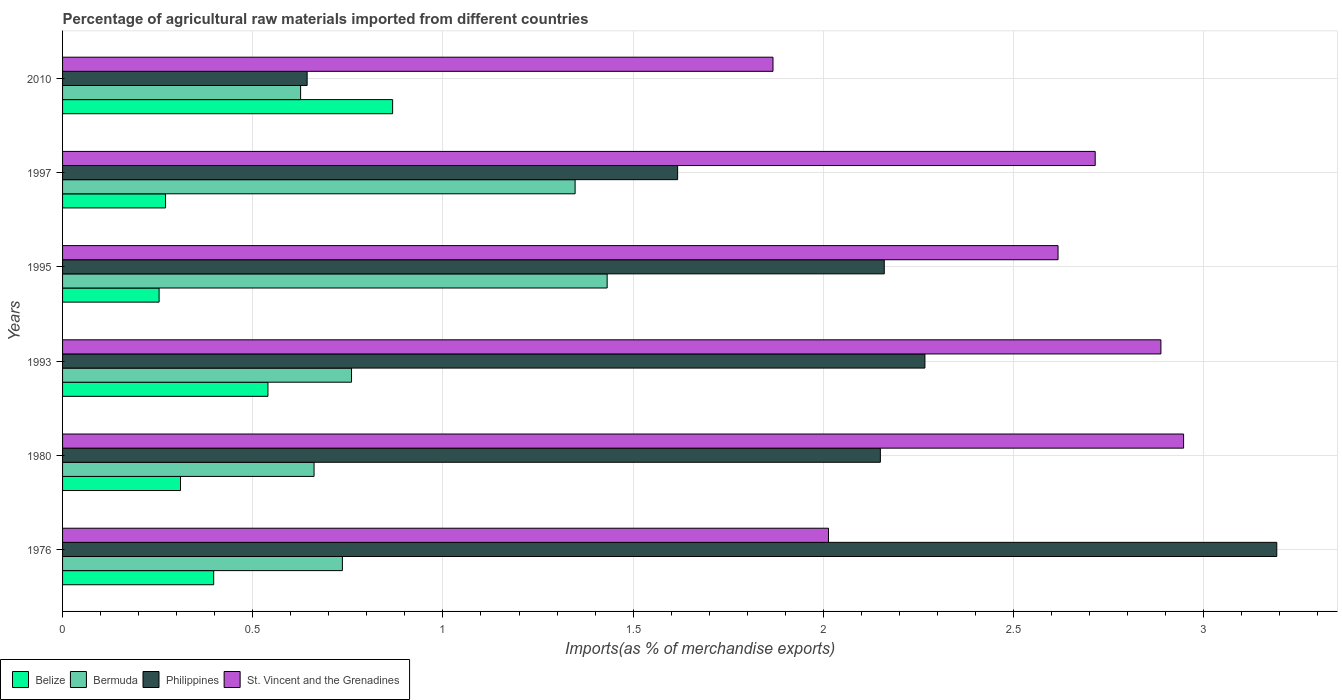How many different coloured bars are there?
Provide a succinct answer. 4. How many bars are there on the 6th tick from the top?
Provide a short and direct response. 4. What is the label of the 4th group of bars from the top?
Offer a very short reply. 1993. What is the percentage of imports to different countries in Belize in 1993?
Ensure brevity in your answer.  0.54. Across all years, what is the maximum percentage of imports to different countries in Philippines?
Provide a short and direct response. 3.19. Across all years, what is the minimum percentage of imports to different countries in Philippines?
Make the answer very short. 0.64. In which year was the percentage of imports to different countries in Philippines maximum?
Give a very brief answer. 1976. In which year was the percentage of imports to different countries in Bermuda minimum?
Make the answer very short. 2010. What is the total percentage of imports to different countries in Bermuda in the graph?
Offer a very short reply. 5.56. What is the difference between the percentage of imports to different countries in Philippines in 1995 and that in 2010?
Your answer should be very brief. 1.52. What is the difference between the percentage of imports to different countries in St. Vincent and the Grenadines in 1993 and the percentage of imports to different countries in Philippines in 1980?
Offer a very short reply. 0.74. What is the average percentage of imports to different countries in Philippines per year?
Your response must be concise. 2. In the year 1997, what is the difference between the percentage of imports to different countries in Belize and percentage of imports to different countries in St. Vincent and the Grenadines?
Your answer should be very brief. -2.44. What is the ratio of the percentage of imports to different countries in Belize in 1976 to that in 1997?
Provide a succinct answer. 1.47. Is the percentage of imports to different countries in Bermuda in 1993 less than that in 1997?
Your answer should be compact. Yes. What is the difference between the highest and the second highest percentage of imports to different countries in St. Vincent and the Grenadines?
Ensure brevity in your answer.  0.06. What is the difference between the highest and the lowest percentage of imports to different countries in Philippines?
Give a very brief answer. 2.55. What does the 1st bar from the top in 1997 represents?
Keep it short and to the point. St. Vincent and the Grenadines. What does the 4th bar from the bottom in 2010 represents?
Offer a terse response. St. Vincent and the Grenadines. How many bars are there?
Your answer should be very brief. 24. Are all the bars in the graph horizontal?
Ensure brevity in your answer.  Yes. What is the difference between two consecutive major ticks on the X-axis?
Your answer should be very brief. 0.5. Does the graph contain any zero values?
Provide a short and direct response. No. Where does the legend appear in the graph?
Offer a very short reply. Bottom left. How many legend labels are there?
Your answer should be very brief. 4. What is the title of the graph?
Offer a very short reply. Percentage of agricultural raw materials imported from different countries. Does "Least developed countries" appear as one of the legend labels in the graph?
Make the answer very short. No. What is the label or title of the X-axis?
Keep it short and to the point. Imports(as % of merchandise exports). What is the label or title of the Y-axis?
Provide a succinct answer. Years. What is the Imports(as % of merchandise exports) in Belize in 1976?
Make the answer very short. 0.4. What is the Imports(as % of merchandise exports) of Bermuda in 1976?
Provide a succinct answer. 0.74. What is the Imports(as % of merchandise exports) of Philippines in 1976?
Keep it short and to the point. 3.19. What is the Imports(as % of merchandise exports) of St. Vincent and the Grenadines in 1976?
Your answer should be very brief. 2.01. What is the Imports(as % of merchandise exports) of Belize in 1980?
Your answer should be very brief. 0.31. What is the Imports(as % of merchandise exports) of Bermuda in 1980?
Make the answer very short. 0.66. What is the Imports(as % of merchandise exports) in Philippines in 1980?
Provide a short and direct response. 2.15. What is the Imports(as % of merchandise exports) of St. Vincent and the Grenadines in 1980?
Your answer should be compact. 2.95. What is the Imports(as % of merchandise exports) in Belize in 1993?
Ensure brevity in your answer.  0.54. What is the Imports(as % of merchandise exports) in Bermuda in 1993?
Offer a very short reply. 0.76. What is the Imports(as % of merchandise exports) of Philippines in 1993?
Ensure brevity in your answer.  2.27. What is the Imports(as % of merchandise exports) in St. Vincent and the Grenadines in 1993?
Keep it short and to the point. 2.89. What is the Imports(as % of merchandise exports) in Belize in 1995?
Your response must be concise. 0.25. What is the Imports(as % of merchandise exports) in Bermuda in 1995?
Provide a short and direct response. 1.43. What is the Imports(as % of merchandise exports) of Philippines in 1995?
Provide a short and direct response. 2.16. What is the Imports(as % of merchandise exports) of St. Vincent and the Grenadines in 1995?
Your answer should be compact. 2.62. What is the Imports(as % of merchandise exports) of Belize in 1997?
Your response must be concise. 0.27. What is the Imports(as % of merchandise exports) in Bermuda in 1997?
Give a very brief answer. 1.35. What is the Imports(as % of merchandise exports) of Philippines in 1997?
Your answer should be very brief. 1.62. What is the Imports(as % of merchandise exports) in St. Vincent and the Grenadines in 1997?
Offer a very short reply. 2.71. What is the Imports(as % of merchandise exports) in Belize in 2010?
Keep it short and to the point. 0.87. What is the Imports(as % of merchandise exports) of Bermuda in 2010?
Offer a very short reply. 0.63. What is the Imports(as % of merchandise exports) in Philippines in 2010?
Your answer should be compact. 0.64. What is the Imports(as % of merchandise exports) of St. Vincent and the Grenadines in 2010?
Your response must be concise. 1.87. Across all years, what is the maximum Imports(as % of merchandise exports) of Belize?
Provide a succinct answer. 0.87. Across all years, what is the maximum Imports(as % of merchandise exports) of Bermuda?
Offer a terse response. 1.43. Across all years, what is the maximum Imports(as % of merchandise exports) in Philippines?
Ensure brevity in your answer.  3.19. Across all years, what is the maximum Imports(as % of merchandise exports) in St. Vincent and the Grenadines?
Your answer should be compact. 2.95. Across all years, what is the minimum Imports(as % of merchandise exports) in Belize?
Your response must be concise. 0.25. Across all years, what is the minimum Imports(as % of merchandise exports) in Bermuda?
Offer a very short reply. 0.63. Across all years, what is the minimum Imports(as % of merchandise exports) in Philippines?
Offer a very short reply. 0.64. Across all years, what is the minimum Imports(as % of merchandise exports) in St. Vincent and the Grenadines?
Offer a terse response. 1.87. What is the total Imports(as % of merchandise exports) in Belize in the graph?
Your answer should be compact. 2.64. What is the total Imports(as % of merchandise exports) in Bermuda in the graph?
Your answer should be compact. 5.56. What is the total Imports(as % of merchandise exports) of Philippines in the graph?
Your answer should be compact. 12.03. What is the total Imports(as % of merchandise exports) of St. Vincent and the Grenadines in the graph?
Offer a terse response. 15.05. What is the difference between the Imports(as % of merchandise exports) of Belize in 1976 and that in 1980?
Your answer should be compact. 0.09. What is the difference between the Imports(as % of merchandise exports) of Bermuda in 1976 and that in 1980?
Your response must be concise. 0.07. What is the difference between the Imports(as % of merchandise exports) of Philippines in 1976 and that in 1980?
Make the answer very short. 1.04. What is the difference between the Imports(as % of merchandise exports) in St. Vincent and the Grenadines in 1976 and that in 1980?
Offer a very short reply. -0.93. What is the difference between the Imports(as % of merchandise exports) in Belize in 1976 and that in 1993?
Ensure brevity in your answer.  -0.14. What is the difference between the Imports(as % of merchandise exports) of Bermuda in 1976 and that in 1993?
Your response must be concise. -0.02. What is the difference between the Imports(as % of merchandise exports) in Philippines in 1976 and that in 1993?
Keep it short and to the point. 0.93. What is the difference between the Imports(as % of merchandise exports) of St. Vincent and the Grenadines in 1976 and that in 1993?
Keep it short and to the point. -0.87. What is the difference between the Imports(as % of merchandise exports) in Belize in 1976 and that in 1995?
Keep it short and to the point. 0.14. What is the difference between the Imports(as % of merchandise exports) of Bermuda in 1976 and that in 1995?
Ensure brevity in your answer.  -0.7. What is the difference between the Imports(as % of merchandise exports) of Philippines in 1976 and that in 1995?
Provide a short and direct response. 1.03. What is the difference between the Imports(as % of merchandise exports) in St. Vincent and the Grenadines in 1976 and that in 1995?
Offer a very short reply. -0.6. What is the difference between the Imports(as % of merchandise exports) in Belize in 1976 and that in 1997?
Offer a very short reply. 0.13. What is the difference between the Imports(as % of merchandise exports) in Bermuda in 1976 and that in 1997?
Provide a short and direct response. -0.61. What is the difference between the Imports(as % of merchandise exports) in Philippines in 1976 and that in 1997?
Ensure brevity in your answer.  1.58. What is the difference between the Imports(as % of merchandise exports) of St. Vincent and the Grenadines in 1976 and that in 1997?
Ensure brevity in your answer.  -0.7. What is the difference between the Imports(as % of merchandise exports) of Belize in 1976 and that in 2010?
Your response must be concise. -0.47. What is the difference between the Imports(as % of merchandise exports) of Bermuda in 1976 and that in 2010?
Your response must be concise. 0.11. What is the difference between the Imports(as % of merchandise exports) in Philippines in 1976 and that in 2010?
Offer a very short reply. 2.55. What is the difference between the Imports(as % of merchandise exports) of St. Vincent and the Grenadines in 1976 and that in 2010?
Keep it short and to the point. 0.15. What is the difference between the Imports(as % of merchandise exports) in Belize in 1980 and that in 1993?
Keep it short and to the point. -0.23. What is the difference between the Imports(as % of merchandise exports) of Bermuda in 1980 and that in 1993?
Make the answer very short. -0.1. What is the difference between the Imports(as % of merchandise exports) in Philippines in 1980 and that in 1993?
Offer a very short reply. -0.12. What is the difference between the Imports(as % of merchandise exports) of St. Vincent and the Grenadines in 1980 and that in 1993?
Your answer should be compact. 0.06. What is the difference between the Imports(as % of merchandise exports) in Belize in 1980 and that in 1995?
Your answer should be very brief. 0.06. What is the difference between the Imports(as % of merchandise exports) of Bermuda in 1980 and that in 1995?
Keep it short and to the point. -0.77. What is the difference between the Imports(as % of merchandise exports) of Philippines in 1980 and that in 1995?
Offer a terse response. -0.01. What is the difference between the Imports(as % of merchandise exports) in St. Vincent and the Grenadines in 1980 and that in 1995?
Offer a terse response. 0.33. What is the difference between the Imports(as % of merchandise exports) in Belize in 1980 and that in 1997?
Make the answer very short. 0.04. What is the difference between the Imports(as % of merchandise exports) of Bermuda in 1980 and that in 1997?
Your answer should be compact. -0.69. What is the difference between the Imports(as % of merchandise exports) in Philippines in 1980 and that in 1997?
Your response must be concise. 0.53. What is the difference between the Imports(as % of merchandise exports) in St. Vincent and the Grenadines in 1980 and that in 1997?
Give a very brief answer. 0.23. What is the difference between the Imports(as % of merchandise exports) of Belize in 1980 and that in 2010?
Offer a terse response. -0.56. What is the difference between the Imports(as % of merchandise exports) of Bermuda in 1980 and that in 2010?
Ensure brevity in your answer.  0.04. What is the difference between the Imports(as % of merchandise exports) of Philippines in 1980 and that in 2010?
Offer a very short reply. 1.51. What is the difference between the Imports(as % of merchandise exports) in St. Vincent and the Grenadines in 1980 and that in 2010?
Provide a short and direct response. 1.08. What is the difference between the Imports(as % of merchandise exports) of Belize in 1993 and that in 1995?
Make the answer very short. 0.29. What is the difference between the Imports(as % of merchandise exports) in Bermuda in 1993 and that in 1995?
Give a very brief answer. -0.67. What is the difference between the Imports(as % of merchandise exports) in Philippines in 1993 and that in 1995?
Offer a very short reply. 0.11. What is the difference between the Imports(as % of merchandise exports) of St. Vincent and the Grenadines in 1993 and that in 1995?
Provide a succinct answer. 0.27. What is the difference between the Imports(as % of merchandise exports) of Belize in 1993 and that in 1997?
Your answer should be compact. 0.27. What is the difference between the Imports(as % of merchandise exports) of Bermuda in 1993 and that in 1997?
Ensure brevity in your answer.  -0.59. What is the difference between the Imports(as % of merchandise exports) in Philippines in 1993 and that in 1997?
Provide a succinct answer. 0.65. What is the difference between the Imports(as % of merchandise exports) of St. Vincent and the Grenadines in 1993 and that in 1997?
Offer a terse response. 0.17. What is the difference between the Imports(as % of merchandise exports) in Belize in 1993 and that in 2010?
Give a very brief answer. -0.33. What is the difference between the Imports(as % of merchandise exports) in Bermuda in 1993 and that in 2010?
Ensure brevity in your answer.  0.13. What is the difference between the Imports(as % of merchandise exports) in Philippines in 1993 and that in 2010?
Make the answer very short. 1.62. What is the difference between the Imports(as % of merchandise exports) of St. Vincent and the Grenadines in 1993 and that in 2010?
Keep it short and to the point. 1.02. What is the difference between the Imports(as % of merchandise exports) in Belize in 1995 and that in 1997?
Make the answer very short. -0.02. What is the difference between the Imports(as % of merchandise exports) of Bermuda in 1995 and that in 1997?
Your response must be concise. 0.08. What is the difference between the Imports(as % of merchandise exports) in Philippines in 1995 and that in 1997?
Provide a short and direct response. 0.54. What is the difference between the Imports(as % of merchandise exports) of St. Vincent and the Grenadines in 1995 and that in 1997?
Provide a succinct answer. -0.1. What is the difference between the Imports(as % of merchandise exports) in Belize in 1995 and that in 2010?
Provide a succinct answer. -0.61. What is the difference between the Imports(as % of merchandise exports) of Bermuda in 1995 and that in 2010?
Provide a succinct answer. 0.81. What is the difference between the Imports(as % of merchandise exports) in Philippines in 1995 and that in 2010?
Your answer should be compact. 1.52. What is the difference between the Imports(as % of merchandise exports) in St. Vincent and the Grenadines in 1995 and that in 2010?
Offer a very short reply. 0.75. What is the difference between the Imports(as % of merchandise exports) of Belize in 1997 and that in 2010?
Give a very brief answer. -0.6. What is the difference between the Imports(as % of merchandise exports) of Bermuda in 1997 and that in 2010?
Offer a terse response. 0.72. What is the difference between the Imports(as % of merchandise exports) of Philippines in 1997 and that in 2010?
Offer a very short reply. 0.97. What is the difference between the Imports(as % of merchandise exports) in St. Vincent and the Grenadines in 1997 and that in 2010?
Provide a short and direct response. 0.85. What is the difference between the Imports(as % of merchandise exports) in Belize in 1976 and the Imports(as % of merchandise exports) in Bermuda in 1980?
Your response must be concise. -0.26. What is the difference between the Imports(as % of merchandise exports) in Belize in 1976 and the Imports(as % of merchandise exports) in Philippines in 1980?
Provide a succinct answer. -1.75. What is the difference between the Imports(as % of merchandise exports) in Belize in 1976 and the Imports(as % of merchandise exports) in St. Vincent and the Grenadines in 1980?
Ensure brevity in your answer.  -2.55. What is the difference between the Imports(as % of merchandise exports) in Bermuda in 1976 and the Imports(as % of merchandise exports) in Philippines in 1980?
Offer a terse response. -1.41. What is the difference between the Imports(as % of merchandise exports) in Bermuda in 1976 and the Imports(as % of merchandise exports) in St. Vincent and the Grenadines in 1980?
Make the answer very short. -2.21. What is the difference between the Imports(as % of merchandise exports) of Philippines in 1976 and the Imports(as % of merchandise exports) of St. Vincent and the Grenadines in 1980?
Ensure brevity in your answer.  0.24. What is the difference between the Imports(as % of merchandise exports) of Belize in 1976 and the Imports(as % of merchandise exports) of Bermuda in 1993?
Give a very brief answer. -0.36. What is the difference between the Imports(as % of merchandise exports) in Belize in 1976 and the Imports(as % of merchandise exports) in Philippines in 1993?
Provide a short and direct response. -1.87. What is the difference between the Imports(as % of merchandise exports) of Belize in 1976 and the Imports(as % of merchandise exports) of St. Vincent and the Grenadines in 1993?
Provide a succinct answer. -2.49. What is the difference between the Imports(as % of merchandise exports) of Bermuda in 1976 and the Imports(as % of merchandise exports) of Philippines in 1993?
Provide a short and direct response. -1.53. What is the difference between the Imports(as % of merchandise exports) of Bermuda in 1976 and the Imports(as % of merchandise exports) of St. Vincent and the Grenadines in 1993?
Offer a terse response. -2.15. What is the difference between the Imports(as % of merchandise exports) in Philippines in 1976 and the Imports(as % of merchandise exports) in St. Vincent and the Grenadines in 1993?
Provide a short and direct response. 0.3. What is the difference between the Imports(as % of merchandise exports) of Belize in 1976 and the Imports(as % of merchandise exports) of Bermuda in 1995?
Offer a very short reply. -1.03. What is the difference between the Imports(as % of merchandise exports) in Belize in 1976 and the Imports(as % of merchandise exports) in Philippines in 1995?
Make the answer very short. -1.76. What is the difference between the Imports(as % of merchandise exports) in Belize in 1976 and the Imports(as % of merchandise exports) in St. Vincent and the Grenadines in 1995?
Your answer should be compact. -2.22. What is the difference between the Imports(as % of merchandise exports) of Bermuda in 1976 and the Imports(as % of merchandise exports) of Philippines in 1995?
Your answer should be very brief. -1.42. What is the difference between the Imports(as % of merchandise exports) in Bermuda in 1976 and the Imports(as % of merchandise exports) in St. Vincent and the Grenadines in 1995?
Your answer should be compact. -1.88. What is the difference between the Imports(as % of merchandise exports) in Philippines in 1976 and the Imports(as % of merchandise exports) in St. Vincent and the Grenadines in 1995?
Your response must be concise. 0.57. What is the difference between the Imports(as % of merchandise exports) of Belize in 1976 and the Imports(as % of merchandise exports) of Bermuda in 1997?
Your response must be concise. -0.95. What is the difference between the Imports(as % of merchandise exports) in Belize in 1976 and the Imports(as % of merchandise exports) in Philippines in 1997?
Ensure brevity in your answer.  -1.22. What is the difference between the Imports(as % of merchandise exports) of Belize in 1976 and the Imports(as % of merchandise exports) of St. Vincent and the Grenadines in 1997?
Ensure brevity in your answer.  -2.32. What is the difference between the Imports(as % of merchandise exports) in Bermuda in 1976 and the Imports(as % of merchandise exports) in Philippines in 1997?
Ensure brevity in your answer.  -0.88. What is the difference between the Imports(as % of merchandise exports) in Bermuda in 1976 and the Imports(as % of merchandise exports) in St. Vincent and the Grenadines in 1997?
Keep it short and to the point. -1.98. What is the difference between the Imports(as % of merchandise exports) of Philippines in 1976 and the Imports(as % of merchandise exports) of St. Vincent and the Grenadines in 1997?
Ensure brevity in your answer.  0.48. What is the difference between the Imports(as % of merchandise exports) in Belize in 1976 and the Imports(as % of merchandise exports) in Bermuda in 2010?
Your answer should be very brief. -0.23. What is the difference between the Imports(as % of merchandise exports) in Belize in 1976 and the Imports(as % of merchandise exports) in Philippines in 2010?
Your answer should be compact. -0.25. What is the difference between the Imports(as % of merchandise exports) in Belize in 1976 and the Imports(as % of merchandise exports) in St. Vincent and the Grenadines in 2010?
Your answer should be very brief. -1.47. What is the difference between the Imports(as % of merchandise exports) in Bermuda in 1976 and the Imports(as % of merchandise exports) in Philippines in 2010?
Offer a terse response. 0.09. What is the difference between the Imports(as % of merchandise exports) in Bermuda in 1976 and the Imports(as % of merchandise exports) in St. Vincent and the Grenadines in 2010?
Provide a succinct answer. -1.13. What is the difference between the Imports(as % of merchandise exports) in Philippines in 1976 and the Imports(as % of merchandise exports) in St. Vincent and the Grenadines in 2010?
Your answer should be compact. 1.32. What is the difference between the Imports(as % of merchandise exports) of Belize in 1980 and the Imports(as % of merchandise exports) of Bermuda in 1993?
Give a very brief answer. -0.45. What is the difference between the Imports(as % of merchandise exports) in Belize in 1980 and the Imports(as % of merchandise exports) in Philippines in 1993?
Your answer should be compact. -1.96. What is the difference between the Imports(as % of merchandise exports) in Belize in 1980 and the Imports(as % of merchandise exports) in St. Vincent and the Grenadines in 1993?
Your answer should be compact. -2.58. What is the difference between the Imports(as % of merchandise exports) in Bermuda in 1980 and the Imports(as % of merchandise exports) in Philippines in 1993?
Give a very brief answer. -1.61. What is the difference between the Imports(as % of merchandise exports) of Bermuda in 1980 and the Imports(as % of merchandise exports) of St. Vincent and the Grenadines in 1993?
Offer a very short reply. -2.23. What is the difference between the Imports(as % of merchandise exports) in Philippines in 1980 and the Imports(as % of merchandise exports) in St. Vincent and the Grenadines in 1993?
Make the answer very short. -0.74. What is the difference between the Imports(as % of merchandise exports) of Belize in 1980 and the Imports(as % of merchandise exports) of Bermuda in 1995?
Your response must be concise. -1.12. What is the difference between the Imports(as % of merchandise exports) in Belize in 1980 and the Imports(as % of merchandise exports) in Philippines in 1995?
Make the answer very short. -1.85. What is the difference between the Imports(as % of merchandise exports) of Belize in 1980 and the Imports(as % of merchandise exports) of St. Vincent and the Grenadines in 1995?
Provide a succinct answer. -2.31. What is the difference between the Imports(as % of merchandise exports) in Bermuda in 1980 and the Imports(as % of merchandise exports) in Philippines in 1995?
Give a very brief answer. -1.5. What is the difference between the Imports(as % of merchandise exports) of Bermuda in 1980 and the Imports(as % of merchandise exports) of St. Vincent and the Grenadines in 1995?
Your response must be concise. -1.96. What is the difference between the Imports(as % of merchandise exports) of Philippines in 1980 and the Imports(as % of merchandise exports) of St. Vincent and the Grenadines in 1995?
Your answer should be compact. -0.47. What is the difference between the Imports(as % of merchandise exports) in Belize in 1980 and the Imports(as % of merchandise exports) in Bermuda in 1997?
Your response must be concise. -1.04. What is the difference between the Imports(as % of merchandise exports) of Belize in 1980 and the Imports(as % of merchandise exports) of Philippines in 1997?
Provide a succinct answer. -1.31. What is the difference between the Imports(as % of merchandise exports) in Belize in 1980 and the Imports(as % of merchandise exports) in St. Vincent and the Grenadines in 1997?
Keep it short and to the point. -2.4. What is the difference between the Imports(as % of merchandise exports) of Bermuda in 1980 and the Imports(as % of merchandise exports) of Philippines in 1997?
Offer a very short reply. -0.96. What is the difference between the Imports(as % of merchandise exports) of Bermuda in 1980 and the Imports(as % of merchandise exports) of St. Vincent and the Grenadines in 1997?
Your answer should be very brief. -2.05. What is the difference between the Imports(as % of merchandise exports) of Philippines in 1980 and the Imports(as % of merchandise exports) of St. Vincent and the Grenadines in 1997?
Your answer should be very brief. -0.56. What is the difference between the Imports(as % of merchandise exports) of Belize in 1980 and the Imports(as % of merchandise exports) of Bermuda in 2010?
Offer a terse response. -0.32. What is the difference between the Imports(as % of merchandise exports) in Belize in 1980 and the Imports(as % of merchandise exports) in Philippines in 2010?
Provide a short and direct response. -0.33. What is the difference between the Imports(as % of merchandise exports) in Belize in 1980 and the Imports(as % of merchandise exports) in St. Vincent and the Grenadines in 2010?
Keep it short and to the point. -1.56. What is the difference between the Imports(as % of merchandise exports) of Bermuda in 1980 and the Imports(as % of merchandise exports) of Philippines in 2010?
Make the answer very short. 0.02. What is the difference between the Imports(as % of merchandise exports) of Bermuda in 1980 and the Imports(as % of merchandise exports) of St. Vincent and the Grenadines in 2010?
Give a very brief answer. -1.21. What is the difference between the Imports(as % of merchandise exports) in Philippines in 1980 and the Imports(as % of merchandise exports) in St. Vincent and the Grenadines in 2010?
Provide a short and direct response. 0.28. What is the difference between the Imports(as % of merchandise exports) in Belize in 1993 and the Imports(as % of merchandise exports) in Bermuda in 1995?
Your answer should be very brief. -0.89. What is the difference between the Imports(as % of merchandise exports) of Belize in 1993 and the Imports(as % of merchandise exports) of Philippines in 1995?
Your answer should be compact. -1.62. What is the difference between the Imports(as % of merchandise exports) of Belize in 1993 and the Imports(as % of merchandise exports) of St. Vincent and the Grenadines in 1995?
Offer a terse response. -2.08. What is the difference between the Imports(as % of merchandise exports) of Bermuda in 1993 and the Imports(as % of merchandise exports) of Philippines in 1995?
Your response must be concise. -1.4. What is the difference between the Imports(as % of merchandise exports) in Bermuda in 1993 and the Imports(as % of merchandise exports) in St. Vincent and the Grenadines in 1995?
Your response must be concise. -1.86. What is the difference between the Imports(as % of merchandise exports) in Philippines in 1993 and the Imports(as % of merchandise exports) in St. Vincent and the Grenadines in 1995?
Provide a short and direct response. -0.35. What is the difference between the Imports(as % of merchandise exports) in Belize in 1993 and the Imports(as % of merchandise exports) in Bermuda in 1997?
Offer a terse response. -0.81. What is the difference between the Imports(as % of merchandise exports) of Belize in 1993 and the Imports(as % of merchandise exports) of Philippines in 1997?
Give a very brief answer. -1.08. What is the difference between the Imports(as % of merchandise exports) of Belize in 1993 and the Imports(as % of merchandise exports) of St. Vincent and the Grenadines in 1997?
Your response must be concise. -2.17. What is the difference between the Imports(as % of merchandise exports) of Bermuda in 1993 and the Imports(as % of merchandise exports) of Philippines in 1997?
Your response must be concise. -0.86. What is the difference between the Imports(as % of merchandise exports) of Bermuda in 1993 and the Imports(as % of merchandise exports) of St. Vincent and the Grenadines in 1997?
Ensure brevity in your answer.  -1.96. What is the difference between the Imports(as % of merchandise exports) in Philippines in 1993 and the Imports(as % of merchandise exports) in St. Vincent and the Grenadines in 1997?
Provide a succinct answer. -0.45. What is the difference between the Imports(as % of merchandise exports) in Belize in 1993 and the Imports(as % of merchandise exports) in Bermuda in 2010?
Offer a terse response. -0.09. What is the difference between the Imports(as % of merchandise exports) in Belize in 1993 and the Imports(as % of merchandise exports) in Philippines in 2010?
Provide a succinct answer. -0.1. What is the difference between the Imports(as % of merchandise exports) in Belize in 1993 and the Imports(as % of merchandise exports) in St. Vincent and the Grenadines in 2010?
Make the answer very short. -1.33. What is the difference between the Imports(as % of merchandise exports) in Bermuda in 1993 and the Imports(as % of merchandise exports) in Philippines in 2010?
Your answer should be compact. 0.12. What is the difference between the Imports(as % of merchandise exports) in Bermuda in 1993 and the Imports(as % of merchandise exports) in St. Vincent and the Grenadines in 2010?
Provide a short and direct response. -1.11. What is the difference between the Imports(as % of merchandise exports) of Philippines in 1993 and the Imports(as % of merchandise exports) of St. Vincent and the Grenadines in 2010?
Give a very brief answer. 0.4. What is the difference between the Imports(as % of merchandise exports) of Belize in 1995 and the Imports(as % of merchandise exports) of Bermuda in 1997?
Provide a succinct answer. -1.09. What is the difference between the Imports(as % of merchandise exports) in Belize in 1995 and the Imports(as % of merchandise exports) in Philippines in 1997?
Offer a very short reply. -1.36. What is the difference between the Imports(as % of merchandise exports) in Belize in 1995 and the Imports(as % of merchandise exports) in St. Vincent and the Grenadines in 1997?
Make the answer very short. -2.46. What is the difference between the Imports(as % of merchandise exports) of Bermuda in 1995 and the Imports(as % of merchandise exports) of Philippines in 1997?
Give a very brief answer. -0.19. What is the difference between the Imports(as % of merchandise exports) of Bermuda in 1995 and the Imports(as % of merchandise exports) of St. Vincent and the Grenadines in 1997?
Make the answer very short. -1.28. What is the difference between the Imports(as % of merchandise exports) in Philippines in 1995 and the Imports(as % of merchandise exports) in St. Vincent and the Grenadines in 1997?
Make the answer very short. -0.55. What is the difference between the Imports(as % of merchandise exports) of Belize in 1995 and the Imports(as % of merchandise exports) of Bermuda in 2010?
Your answer should be compact. -0.37. What is the difference between the Imports(as % of merchandise exports) in Belize in 1995 and the Imports(as % of merchandise exports) in Philippines in 2010?
Your answer should be very brief. -0.39. What is the difference between the Imports(as % of merchandise exports) of Belize in 1995 and the Imports(as % of merchandise exports) of St. Vincent and the Grenadines in 2010?
Your response must be concise. -1.61. What is the difference between the Imports(as % of merchandise exports) in Bermuda in 1995 and the Imports(as % of merchandise exports) in Philippines in 2010?
Provide a short and direct response. 0.79. What is the difference between the Imports(as % of merchandise exports) of Bermuda in 1995 and the Imports(as % of merchandise exports) of St. Vincent and the Grenadines in 2010?
Provide a short and direct response. -0.44. What is the difference between the Imports(as % of merchandise exports) of Philippines in 1995 and the Imports(as % of merchandise exports) of St. Vincent and the Grenadines in 2010?
Your response must be concise. 0.29. What is the difference between the Imports(as % of merchandise exports) in Belize in 1997 and the Imports(as % of merchandise exports) in Bermuda in 2010?
Ensure brevity in your answer.  -0.35. What is the difference between the Imports(as % of merchandise exports) of Belize in 1997 and the Imports(as % of merchandise exports) of Philippines in 2010?
Keep it short and to the point. -0.37. What is the difference between the Imports(as % of merchandise exports) of Belize in 1997 and the Imports(as % of merchandise exports) of St. Vincent and the Grenadines in 2010?
Ensure brevity in your answer.  -1.6. What is the difference between the Imports(as % of merchandise exports) of Bermuda in 1997 and the Imports(as % of merchandise exports) of Philippines in 2010?
Your response must be concise. 0.7. What is the difference between the Imports(as % of merchandise exports) of Bermuda in 1997 and the Imports(as % of merchandise exports) of St. Vincent and the Grenadines in 2010?
Make the answer very short. -0.52. What is the difference between the Imports(as % of merchandise exports) of Philippines in 1997 and the Imports(as % of merchandise exports) of St. Vincent and the Grenadines in 2010?
Offer a very short reply. -0.25. What is the average Imports(as % of merchandise exports) in Belize per year?
Offer a very short reply. 0.44. What is the average Imports(as % of merchandise exports) of Bermuda per year?
Keep it short and to the point. 0.93. What is the average Imports(as % of merchandise exports) in Philippines per year?
Give a very brief answer. 2. What is the average Imports(as % of merchandise exports) of St. Vincent and the Grenadines per year?
Provide a short and direct response. 2.51. In the year 1976, what is the difference between the Imports(as % of merchandise exports) in Belize and Imports(as % of merchandise exports) in Bermuda?
Ensure brevity in your answer.  -0.34. In the year 1976, what is the difference between the Imports(as % of merchandise exports) of Belize and Imports(as % of merchandise exports) of Philippines?
Provide a short and direct response. -2.79. In the year 1976, what is the difference between the Imports(as % of merchandise exports) in Belize and Imports(as % of merchandise exports) in St. Vincent and the Grenadines?
Ensure brevity in your answer.  -1.62. In the year 1976, what is the difference between the Imports(as % of merchandise exports) in Bermuda and Imports(as % of merchandise exports) in Philippines?
Provide a succinct answer. -2.46. In the year 1976, what is the difference between the Imports(as % of merchandise exports) of Bermuda and Imports(as % of merchandise exports) of St. Vincent and the Grenadines?
Offer a very short reply. -1.28. In the year 1976, what is the difference between the Imports(as % of merchandise exports) of Philippines and Imports(as % of merchandise exports) of St. Vincent and the Grenadines?
Your response must be concise. 1.18. In the year 1980, what is the difference between the Imports(as % of merchandise exports) in Belize and Imports(as % of merchandise exports) in Bermuda?
Offer a very short reply. -0.35. In the year 1980, what is the difference between the Imports(as % of merchandise exports) in Belize and Imports(as % of merchandise exports) in Philippines?
Make the answer very short. -1.84. In the year 1980, what is the difference between the Imports(as % of merchandise exports) of Belize and Imports(as % of merchandise exports) of St. Vincent and the Grenadines?
Give a very brief answer. -2.64. In the year 1980, what is the difference between the Imports(as % of merchandise exports) of Bermuda and Imports(as % of merchandise exports) of Philippines?
Make the answer very short. -1.49. In the year 1980, what is the difference between the Imports(as % of merchandise exports) of Bermuda and Imports(as % of merchandise exports) of St. Vincent and the Grenadines?
Offer a very short reply. -2.29. In the year 1980, what is the difference between the Imports(as % of merchandise exports) in Philippines and Imports(as % of merchandise exports) in St. Vincent and the Grenadines?
Your response must be concise. -0.8. In the year 1993, what is the difference between the Imports(as % of merchandise exports) of Belize and Imports(as % of merchandise exports) of Bermuda?
Your response must be concise. -0.22. In the year 1993, what is the difference between the Imports(as % of merchandise exports) of Belize and Imports(as % of merchandise exports) of Philippines?
Ensure brevity in your answer.  -1.73. In the year 1993, what is the difference between the Imports(as % of merchandise exports) of Belize and Imports(as % of merchandise exports) of St. Vincent and the Grenadines?
Give a very brief answer. -2.35. In the year 1993, what is the difference between the Imports(as % of merchandise exports) of Bermuda and Imports(as % of merchandise exports) of Philippines?
Keep it short and to the point. -1.51. In the year 1993, what is the difference between the Imports(as % of merchandise exports) in Bermuda and Imports(as % of merchandise exports) in St. Vincent and the Grenadines?
Offer a very short reply. -2.13. In the year 1993, what is the difference between the Imports(as % of merchandise exports) of Philippines and Imports(as % of merchandise exports) of St. Vincent and the Grenadines?
Keep it short and to the point. -0.62. In the year 1995, what is the difference between the Imports(as % of merchandise exports) in Belize and Imports(as % of merchandise exports) in Bermuda?
Your response must be concise. -1.18. In the year 1995, what is the difference between the Imports(as % of merchandise exports) of Belize and Imports(as % of merchandise exports) of Philippines?
Your answer should be very brief. -1.91. In the year 1995, what is the difference between the Imports(as % of merchandise exports) in Belize and Imports(as % of merchandise exports) in St. Vincent and the Grenadines?
Your response must be concise. -2.36. In the year 1995, what is the difference between the Imports(as % of merchandise exports) of Bermuda and Imports(as % of merchandise exports) of Philippines?
Your response must be concise. -0.73. In the year 1995, what is the difference between the Imports(as % of merchandise exports) of Bermuda and Imports(as % of merchandise exports) of St. Vincent and the Grenadines?
Your response must be concise. -1.19. In the year 1995, what is the difference between the Imports(as % of merchandise exports) of Philippines and Imports(as % of merchandise exports) of St. Vincent and the Grenadines?
Your answer should be very brief. -0.46. In the year 1997, what is the difference between the Imports(as % of merchandise exports) in Belize and Imports(as % of merchandise exports) in Bermuda?
Give a very brief answer. -1.08. In the year 1997, what is the difference between the Imports(as % of merchandise exports) of Belize and Imports(as % of merchandise exports) of Philippines?
Offer a terse response. -1.35. In the year 1997, what is the difference between the Imports(as % of merchandise exports) in Belize and Imports(as % of merchandise exports) in St. Vincent and the Grenadines?
Offer a terse response. -2.44. In the year 1997, what is the difference between the Imports(as % of merchandise exports) of Bermuda and Imports(as % of merchandise exports) of Philippines?
Your answer should be very brief. -0.27. In the year 1997, what is the difference between the Imports(as % of merchandise exports) of Bermuda and Imports(as % of merchandise exports) of St. Vincent and the Grenadines?
Provide a succinct answer. -1.37. In the year 1997, what is the difference between the Imports(as % of merchandise exports) of Philippines and Imports(as % of merchandise exports) of St. Vincent and the Grenadines?
Your answer should be very brief. -1.1. In the year 2010, what is the difference between the Imports(as % of merchandise exports) in Belize and Imports(as % of merchandise exports) in Bermuda?
Your response must be concise. 0.24. In the year 2010, what is the difference between the Imports(as % of merchandise exports) in Belize and Imports(as % of merchandise exports) in Philippines?
Offer a very short reply. 0.22. In the year 2010, what is the difference between the Imports(as % of merchandise exports) of Bermuda and Imports(as % of merchandise exports) of Philippines?
Offer a very short reply. -0.02. In the year 2010, what is the difference between the Imports(as % of merchandise exports) of Bermuda and Imports(as % of merchandise exports) of St. Vincent and the Grenadines?
Your answer should be very brief. -1.24. In the year 2010, what is the difference between the Imports(as % of merchandise exports) of Philippines and Imports(as % of merchandise exports) of St. Vincent and the Grenadines?
Offer a terse response. -1.22. What is the ratio of the Imports(as % of merchandise exports) in Belize in 1976 to that in 1980?
Your answer should be compact. 1.28. What is the ratio of the Imports(as % of merchandise exports) in Bermuda in 1976 to that in 1980?
Give a very brief answer. 1.11. What is the ratio of the Imports(as % of merchandise exports) of Philippines in 1976 to that in 1980?
Your answer should be very brief. 1.48. What is the ratio of the Imports(as % of merchandise exports) in St. Vincent and the Grenadines in 1976 to that in 1980?
Provide a succinct answer. 0.68. What is the ratio of the Imports(as % of merchandise exports) in Belize in 1976 to that in 1993?
Give a very brief answer. 0.74. What is the ratio of the Imports(as % of merchandise exports) in Bermuda in 1976 to that in 1993?
Offer a terse response. 0.97. What is the ratio of the Imports(as % of merchandise exports) in Philippines in 1976 to that in 1993?
Give a very brief answer. 1.41. What is the ratio of the Imports(as % of merchandise exports) in St. Vincent and the Grenadines in 1976 to that in 1993?
Make the answer very short. 0.7. What is the ratio of the Imports(as % of merchandise exports) in Belize in 1976 to that in 1995?
Provide a short and direct response. 1.57. What is the ratio of the Imports(as % of merchandise exports) in Bermuda in 1976 to that in 1995?
Your response must be concise. 0.51. What is the ratio of the Imports(as % of merchandise exports) in Philippines in 1976 to that in 1995?
Your answer should be very brief. 1.48. What is the ratio of the Imports(as % of merchandise exports) of St. Vincent and the Grenadines in 1976 to that in 1995?
Ensure brevity in your answer.  0.77. What is the ratio of the Imports(as % of merchandise exports) in Belize in 1976 to that in 1997?
Make the answer very short. 1.47. What is the ratio of the Imports(as % of merchandise exports) in Bermuda in 1976 to that in 1997?
Make the answer very short. 0.55. What is the ratio of the Imports(as % of merchandise exports) of Philippines in 1976 to that in 1997?
Your response must be concise. 1.97. What is the ratio of the Imports(as % of merchandise exports) of St. Vincent and the Grenadines in 1976 to that in 1997?
Give a very brief answer. 0.74. What is the ratio of the Imports(as % of merchandise exports) in Belize in 1976 to that in 2010?
Keep it short and to the point. 0.46. What is the ratio of the Imports(as % of merchandise exports) of Bermuda in 1976 to that in 2010?
Keep it short and to the point. 1.18. What is the ratio of the Imports(as % of merchandise exports) in Philippines in 1976 to that in 2010?
Provide a short and direct response. 4.96. What is the ratio of the Imports(as % of merchandise exports) in St. Vincent and the Grenadines in 1976 to that in 2010?
Provide a short and direct response. 1.08. What is the ratio of the Imports(as % of merchandise exports) in Belize in 1980 to that in 1993?
Ensure brevity in your answer.  0.57. What is the ratio of the Imports(as % of merchandise exports) of Bermuda in 1980 to that in 1993?
Offer a very short reply. 0.87. What is the ratio of the Imports(as % of merchandise exports) in Philippines in 1980 to that in 1993?
Keep it short and to the point. 0.95. What is the ratio of the Imports(as % of merchandise exports) in St. Vincent and the Grenadines in 1980 to that in 1993?
Provide a short and direct response. 1.02. What is the ratio of the Imports(as % of merchandise exports) in Belize in 1980 to that in 1995?
Provide a succinct answer. 1.22. What is the ratio of the Imports(as % of merchandise exports) in Bermuda in 1980 to that in 1995?
Keep it short and to the point. 0.46. What is the ratio of the Imports(as % of merchandise exports) in St. Vincent and the Grenadines in 1980 to that in 1995?
Keep it short and to the point. 1.13. What is the ratio of the Imports(as % of merchandise exports) in Belize in 1980 to that in 1997?
Keep it short and to the point. 1.15. What is the ratio of the Imports(as % of merchandise exports) of Bermuda in 1980 to that in 1997?
Ensure brevity in your answer.  0.49. What is the ratio of the Imports(as % of merchandise exports) of Philippines in 1980 to that in 1997?
Offer a terse response. 1.33. What is the ratio of the Imports(as % of merchandise exports) in St. Vincent and the Grenadines in 1980 to that in 1997?
Ensure brevity in your answer.  1.09. What is the ratio of the Imports(as % of merchandise exports) of Belize in 1980 to that in 2010?
Offer a terse response. 0.36. What is the ratio of the Imports(as % of merchandise exports) in Bermuda in 1980 to that in 2010?
Provide a succinct answer. 1.06. What is the ratio of the Imports(as % of merchandise exports) of Philippines in 1980 to that in 2010?
Offer a very short reply. 3.34. What is the ratio of the Imports(as % of merchandise exports) in St. Vincent and the Grenadines in 1980 to that in 2010?
Offer a terse response. 1.58. What is the ratio of the Imports(as % of merchandise exports) of Belize in 1993 to that in 1995?
Give a very brief answer. 2.13. What is the ratio of the Imports(as % of merchandise exports) in Bermuda in 1993 to that in 1995?
Ensure brevity in your answer.  0.53. What is the ratio of the Imports(as % of merchandise exports) of Philippines in 1993 to that in 1995?
Provide a short and direct response. 1.05. What is the ratio of the Imports(as % of merchandise exports) of St. Vincent and the Grenadines in 1993 to that in 1995?
Provide a succinct answer. 1.1. What is the ratio of the Imports(as % of merchandise exports) of Belize in 1993 to that in 1997?
Offer a very short reply. 1.99. What is the ratio of the Imports(as % of merchandise exports) in Bermuda in 1993 to that in 1997?
Offer a very short reply. 0.56. What is the ratio of the Imports(as % of merchandise exports) in Philippines in 1993 to that in 1997?
Keep it short and to the point. 1.4. What is the ratio of the Imports(as % of merchandise exports) of St. Vincent and the Grenadines in 1993 to that in 1997?
Your answer should be very brief. 1.06. What is the ratio of the Imports(as % of merchandise exports) in Belize in 1993 to that in 2010?
Your answer should be very brief. 0.62. What is the ratio of the Imports(as % of merchandise exports) of Bermuda in 1993 to that in 2010?
Make the answer very short. 1.21. What is the ratio of the Imports(as % of merchandise exports) of Philippines in 1993 to that in 2010?
Your response must be concise. 3.53. What is the ratio of the Imports(as % of merchandise exports) in St. Vincent and the Grenadines in 1993 to that in 2010?
Provide a succinct answer. 1.55. What is the ratio of the Imports(as % of merchandise exports) in Belize in 1995 to that in 1997?
Offer a very short reply. 0.94. What is the ratio of the Imports(as % of merchandise exports) of Bermuda in 1995 to that in 1997?
Ensure brevity in your answer.  1.06. What is the ratio of the Imports(as % of merchandise exports) of Philippines in 1995 to that in 1997?
Ensure brevity in your answer.  1.34. What is the ratio of the Imports(as % of merchandise exports) in St. Vincent and the Grenadines in 1995 to that in 1997?
Keep it short and to the point. 0.96. What is the ratio of the Imports(as % of merchandise exports) in Belize in 1995 to that in 2010?
Make the answer very short. 0.29. What is the ratio of the Imports(as % of merchandise exports) of Bermuda in 1995 to that in 2010?
Provide a short and direct response. 2.29. What is the ratio of the Imports(as % of merchandise exports) in Philippines in 1995 to that in 2010?
Your answer should be compact. 3.36. What is the ratio of the Imports(as % of merchandise exports) of St. Vincent and the Grenadines in 1995 to that in 2010?
Offer a very short reply. 1.4. What is the ratio of the Imports(as % of merchandise exports) of Belize in 1997 to that in 2010?
Your answer should be compact. 0.31. What is the ratio of the Imports(as % of merchandise exports) in Bermuda in 1997 to that in 2010?
Offer a very short reply. 2.15. What is the ratio of the Imports(as % of merchandise exports) in Philippines in 1997 to that in 2010?
Provide a succinct answer. 2.51. What is the ratio of the Imports(as % of merchandise exports) in St. Vincent and the Grenadines in 1997 to that in 2010?
Give a very brief answer. 1.45. What is the difference between the highest and the second highest Imports(as % of merchandise exports) in Belize?
Provide a succinct answer. 0.33. What is the difference between the highest and the second highest Imports(as % of merchandise exports) in Bermuda?
Ensure brevity in your answer.  0.08. What is the difference between the highest and the second highest Imports(as % of merchandise exports) in Philippines?
Keep it short and to the point. 0.93. What is the difference between the highest and the second highest Imports(as % of merchandise exports) in St. Vincent and the Grenadines?
Keep it short and to the point. 0.06. What is the difference between the highest and the lowest Imports(as % of merchandise exports) of Belize?
Offer a terse response. 0.61. What is the difference between the highest and the lowest Imports(as % of merchandise exports) in Bermuda?
Provide a succinct answer. 0.81. What is the difference between the highest and the lowest Imports(as % of merchandise exports) in Philippines?
Provide a succinct answer. 2.55. What is the difference between the highest and the lowest Imports(as % of merchandise exports) in St. Vincent and the Grenadines?
Provide a short and direct response. 1.08. 